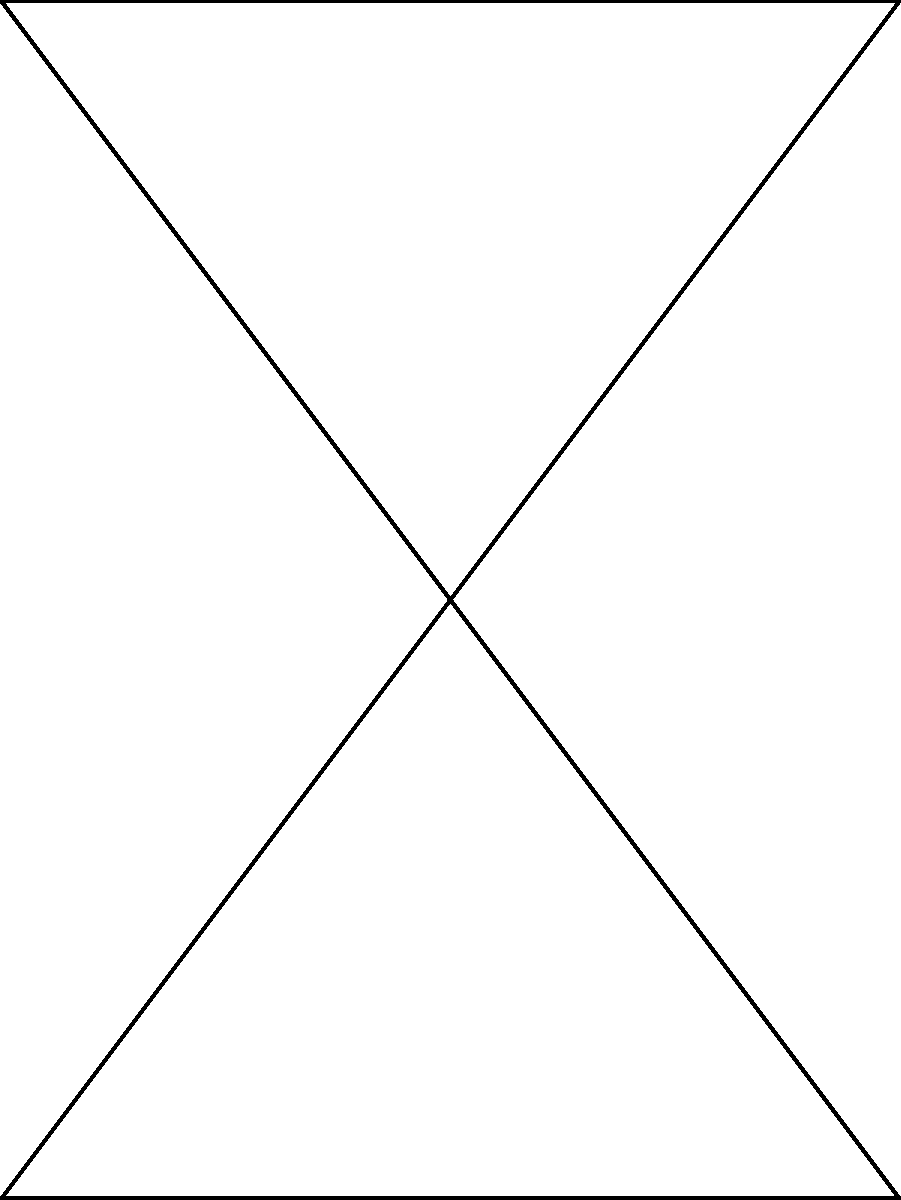For the upcoming literary festival, you're designing a triangular stage represented by triangle ABC on the coordinate plane. The stage needs to be rotated 90° counterclockwise around point O(0,0) for a special performance. If the original coordinates of point C are (3,4), what will be the coordinates of point C after the rotation? To solve this problem, we'll follow these steps:

1) First, recall the formula for rotating a point $(x,y)$ by 90° counterclockwise around the origin:
   $(x,y) \rightarrow (-y,x)$

2) The original coordinates of point C are (3,4).

3) Applying the rotation formula:
   $x_{new} = -y_{original} = -4$
   $y_{new} = x_{original} = 3$

4) Therefore, after the 90° counterclockwise rotation, the new coordinates of point C will be $(-4,3)$.

This rotation will effectively flip the stage over the line $y=x$, with point A moving to (0,3), point B moving to (-4,0), and point C moving to (-4,3).
Answer: $(-4,3)$ 